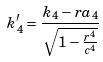<formula> <loc_0><loc_0><loc_500><loc_500>k _ { 4 } ^ { \prime } = \frac { k _ { 4 } - r a _ { 4 } } { \sqrt { 1 - \frac { r ^ { 4 } } { c ^ { 4 } } } }</formula> 